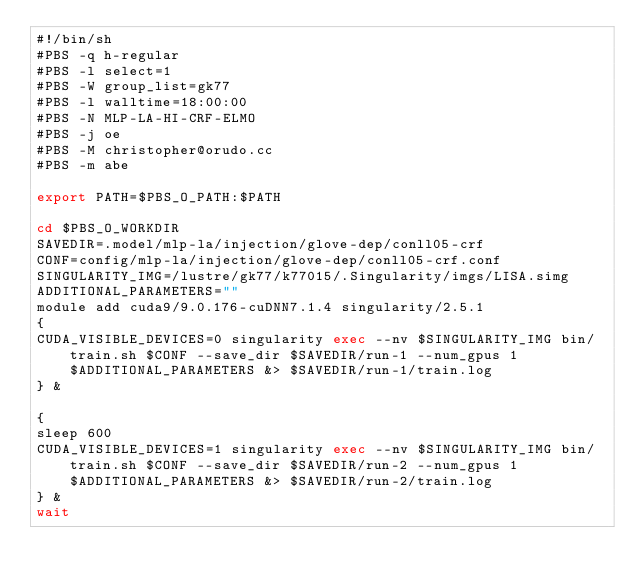<code> <loc_0><loc_0><loc_500><loc_500><_Bash_>#!/bin/sh
#PBS -q h-regular
#PBS -l select=1
#PBS -W group_list=gk77
#PBS -l walltime=18:00:00
#PBS -N MLP-LA-HI-CRF-ELMO
#PBS -j oe
#PBS -M christopher@orudo.cc
#PBS -m abe

export PATH=$PBS_O_PATH:$PATH

cd $PBS_O_WORKDIR
SAVEDIR=.model/mlp-la/injection/glove-dep/conll05-crf
CONF=config/mlp-la/injection/glove-dep/conll05-crf.conf
SINGULARITY_IMG=/lustre/gk77/k77015/.Singularity/imgs/LISA.simg
ADDITIONAL_PARAMETERS=""
module add cuda9/9.0.176-cuDNN7.1.4 singularity/2.5.1
{
CUDA_VISIBLE_DEVICES=0 singularity exec --nv $SINGULARITY_IMG bin/train.sh $CONF --save_dir $SAVEDIR/run-1 --num_gpus 1 $ADDITIONAL_PARAMETERS &> $SAVEDIR/run-1/train.log
} &

{
sleep 600
CUDA_VISIBLE_DEVICES=1 singularity exec --nv $SINGULARITY_IMG bin/train.sh $CONF --save_dir $SAVEDIR/run-2 --num_gpus 1 $ADDITIONAL_PARAMETERS &> $SAVEDIR/run-2/train.log
} &
wait

</code> 